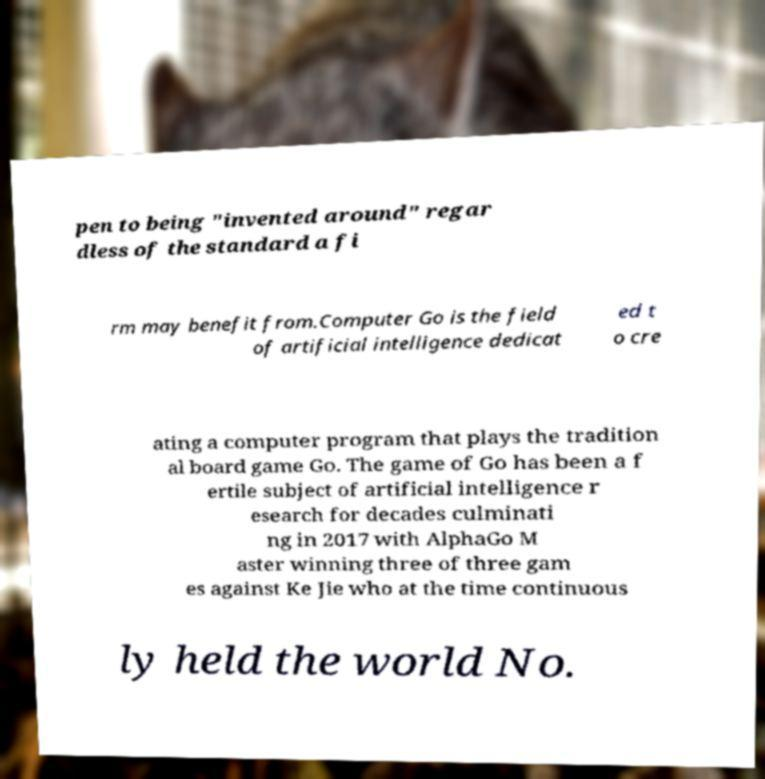What messages or text are displayed in this image? I need them in a readable, typed format. pen to being "invented around" regar dless of the standard a fi rm may benefit from.Computer Go is the field of artificial intelligence dedicat ed t o cre ating a computer program that plays the tradition al board game Go. The game of Go has been a f ertile subject of artificial intelligence r esearch for decades culminati ng in 2017 with AlphaGo M aster winning three of three gam es against Ke Jie who at the time continuous ly held the world No. 